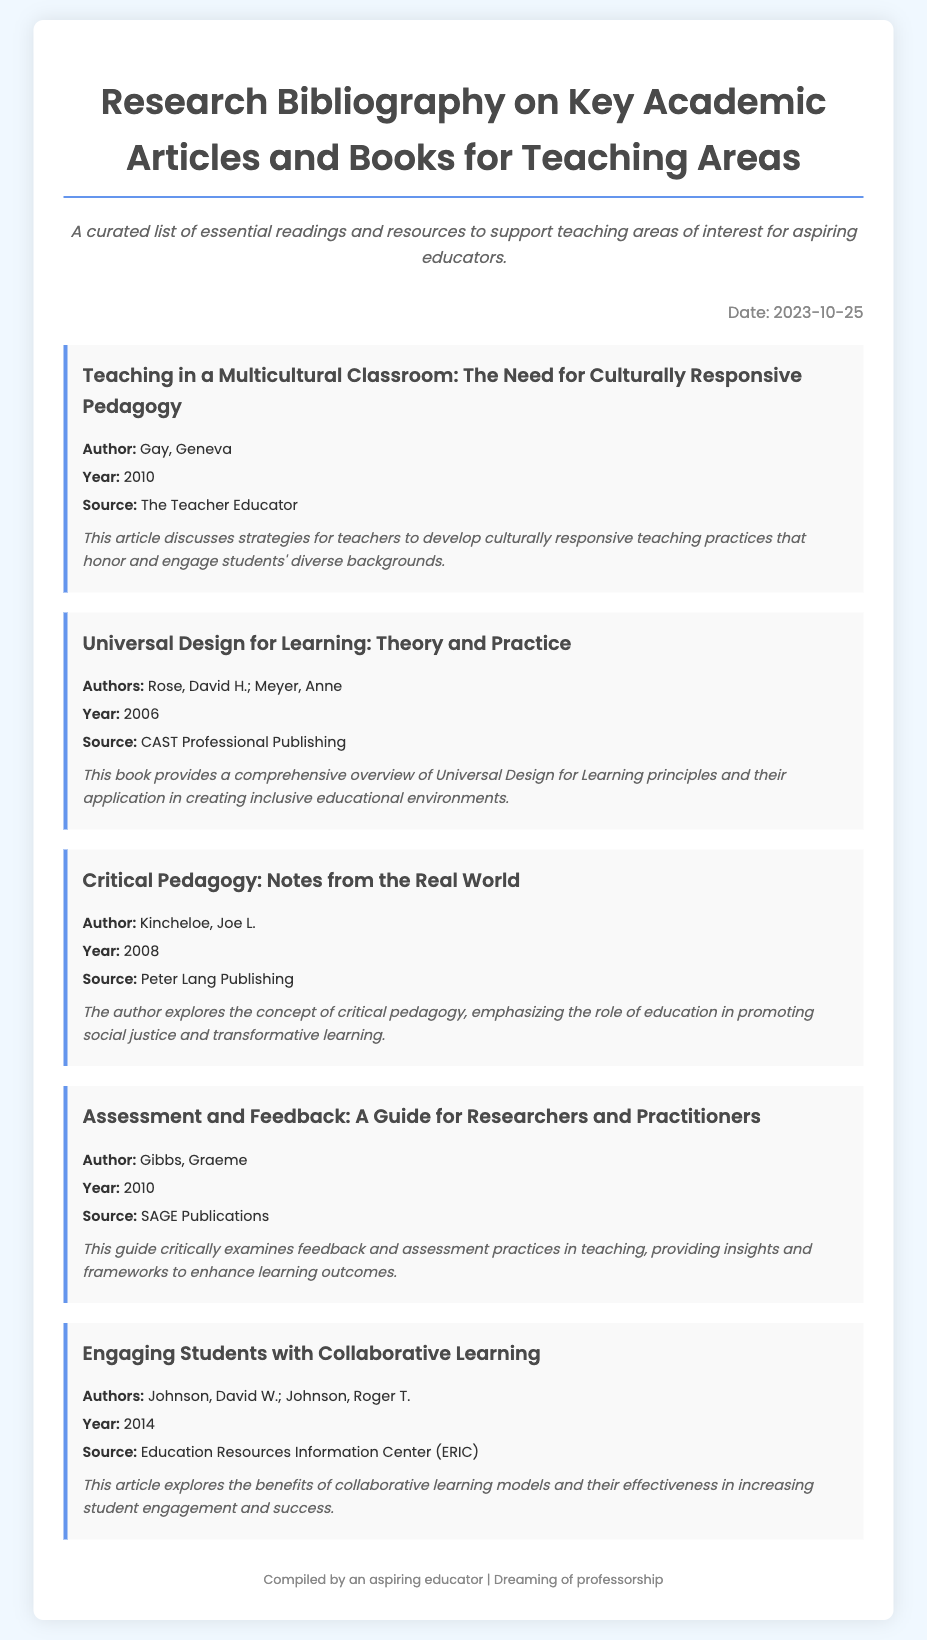What is the title of the first article? The title of the first article is listed at the top of the item's section in the document.
Answer: Teaching in a Multicultural Classroom: The Need for Culturally Responsive Pedagogy Who is the author of the book on Universal Design for Learning? The author of the book is mentioned directly under the title of the respective item.
Answer: Rose, David H.; Meyer, Anne What year was the article on Critical Pedagogy published? The publication year is provided in the details below each item for reference.
Answer: 2008 Which source published the guide on Assessment and Feedback? The source of the guide is stated under the author's name in the document.
Answer: SAGE Publications What is a key theme discussed in the first article? The theme is highlighted in the summary provided beneath the item’s details.
Answer: Culturally responsive teaching practices How many authors contributed to the article on Collaborative Learning? The number of authors can be found by counting the names mentioned in the authors' section.
Answer: 2 What type of document is this bibliography? The document type is discernible from the title and the overall content.
Answer: Research bibliography When was the document compiled? The compilation date is specified clearly in the date section of the document.
Answer: 2023-10-25 